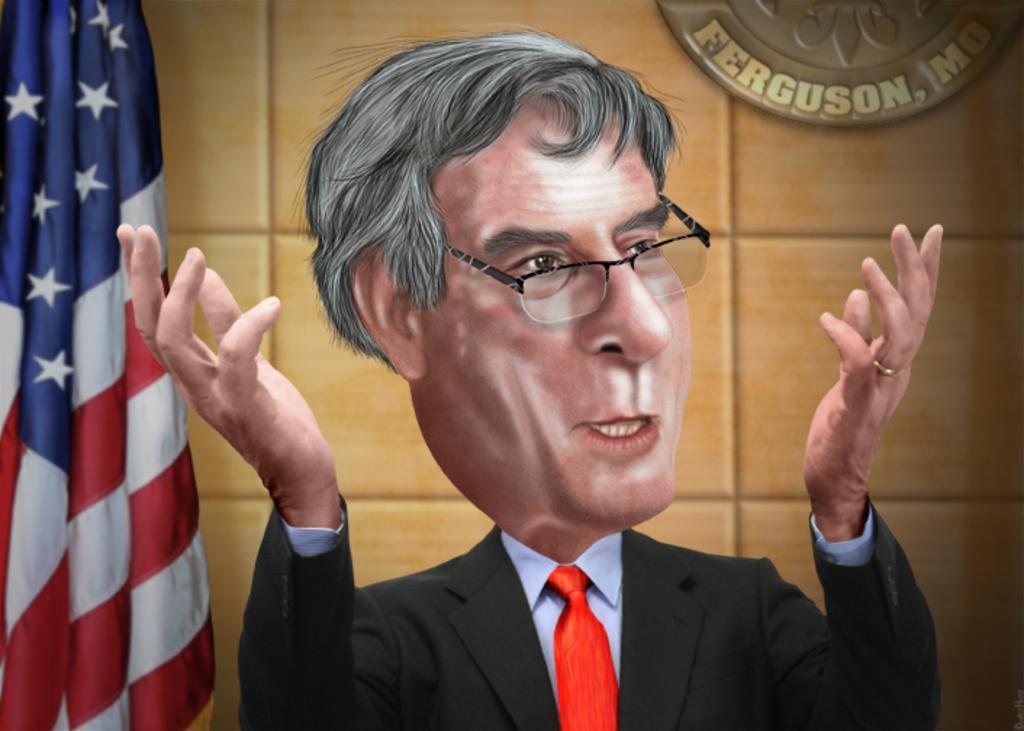Please provide a concise description of this image. There is an animated image of a person who is in coat. On the left side, there is a flag. In the background, there is a hoarding on the wall. 